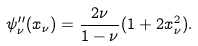Convert formula to latex. <formula><loc_0><loc_0><loc_500><loc_500>\psi ^ { \prime \prime } _ { \nu } ( x _ { \nu } ) = \frac { 2 \nu } { 1 - \nu } ( 1 + 2 x _ { \nu } ^ { 2 } ) .</formula> 